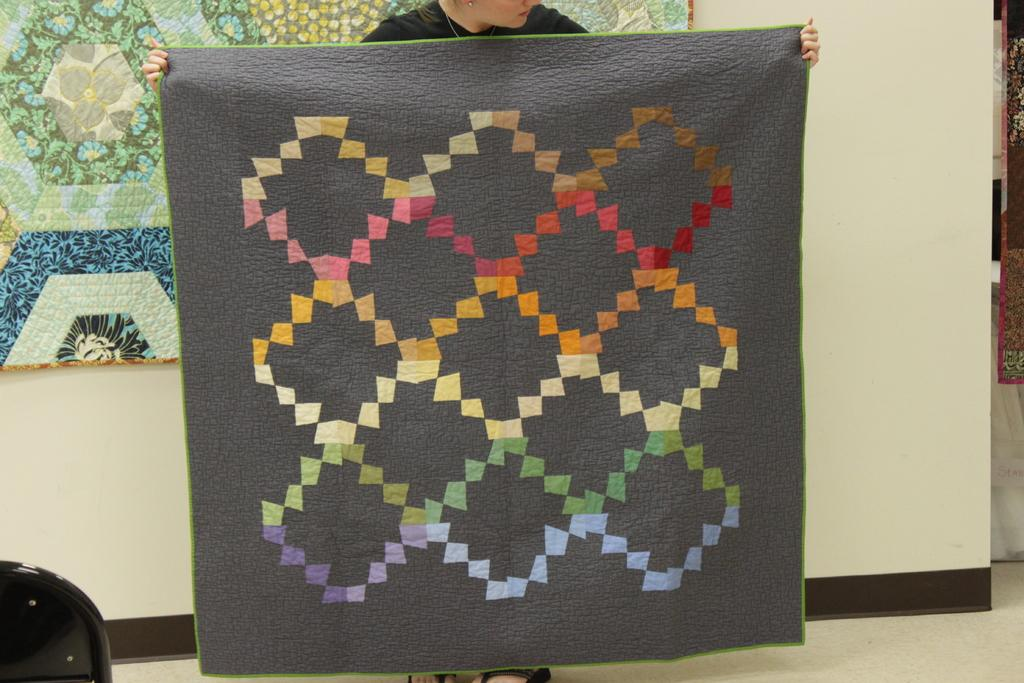What is the main subject of the image? There is a person in the image. What is the person holding in the image? The person is holding a cloth. What part of the room can be seen in the image? The floor is visible in the image. What is visible in the background of the image? There is a wall and clothes in the background of the image. What type of lock can be seen on the hose in the image? There is no hose or lock present in the image. What is the aftermath of the event depicted in the image? The image does not depict an event, so there is no aftermath to describe. 